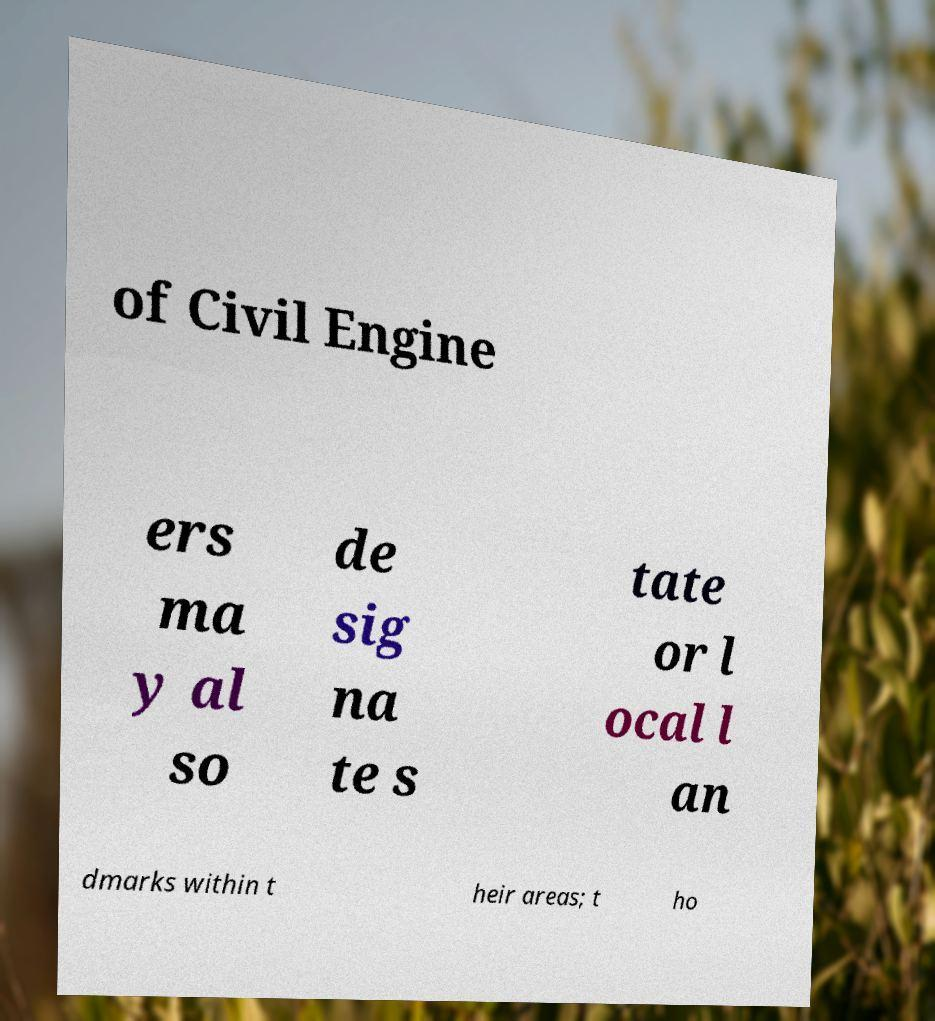Please read and relay the text visible in this image. What does it say? of Civil Engine ers ma y al so de sig na te s tate or l ocal l an dmarks within t heir areas; t ho 